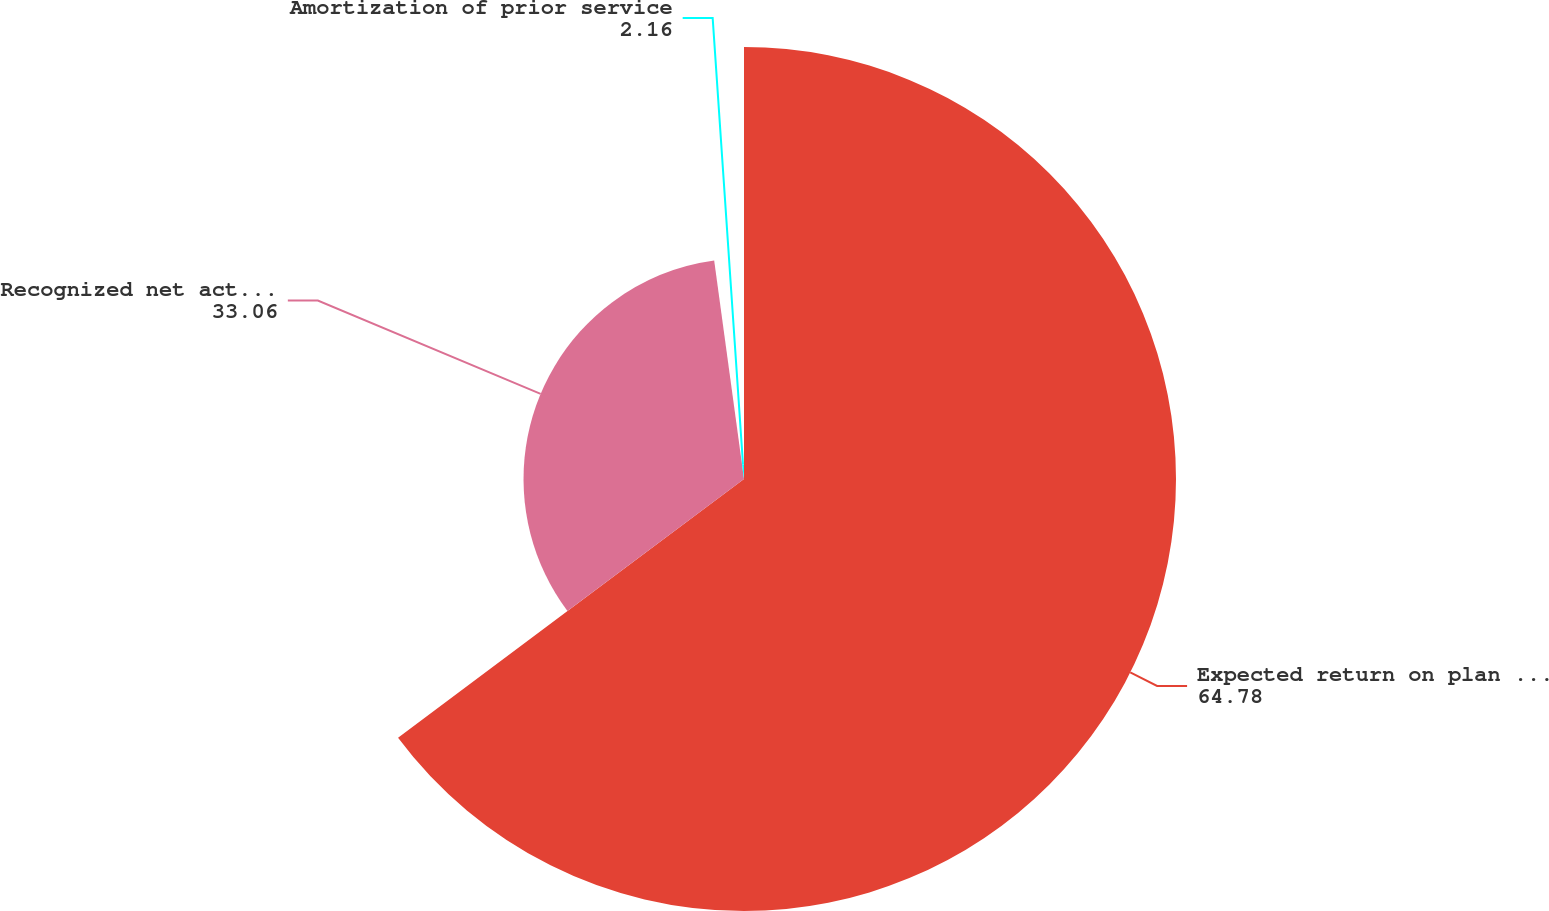Convert chart. <chart><loc_0><loc_0><loc_500><loc_500><pie_chart><fcel>Expected return on plan assets<fcel>Recognized net actuarial<fcel>Amortization of prior service<nl><fcel>64.78%<fcel>33.06%<fcel>2.16%<nl></chart> 